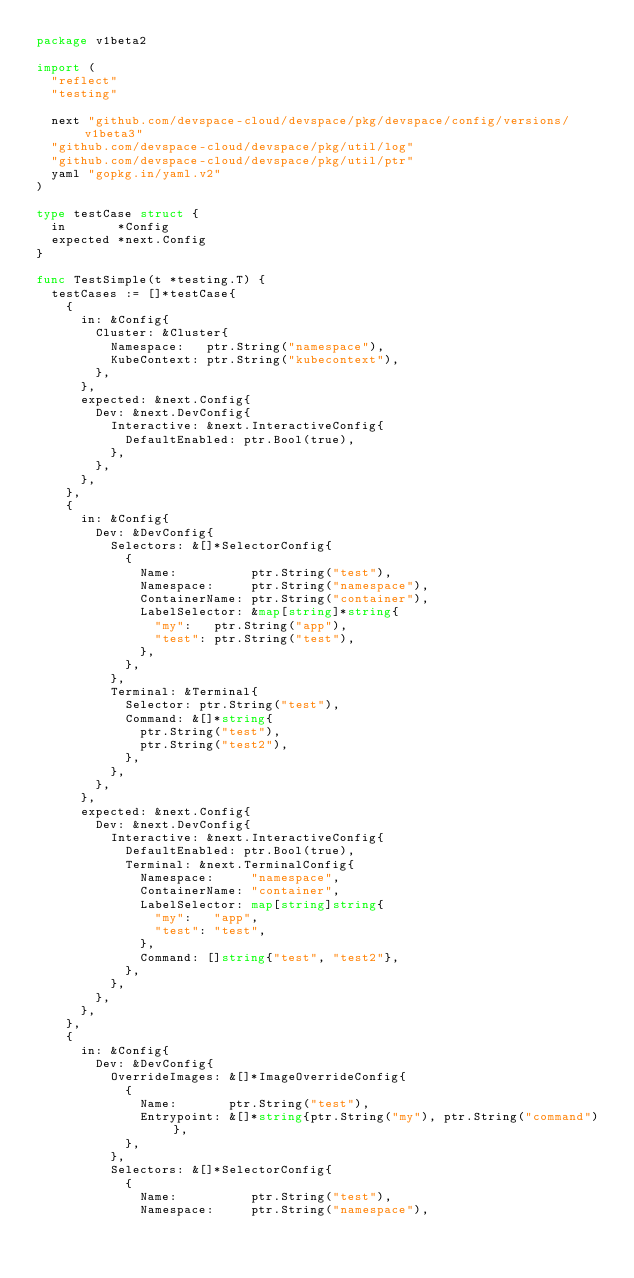Convert code to text. <code><loc_0><loc_0><loc_500><loc_500><_Go_>package v1beta2

import (
	"reflect"
	"testing"

	next "github.com/devspace-cloud/devspace/pkg/devspace/config/versions/v1beta3"
	"github.com/devspace-cloud/devspace/pkg/util/log"
	"github.com/devspace-cloud/devspace/pkg/util/ptr"
	yaml "gopkg.in/yaml.v2"
)

type testCase struct {
	in       *Config
	expected *next.Config
}

func TestSimple(t *testing.T) {
	testCases := []*testCase{
		{
			in: &Config{
				Cluster: &Cluster{
					Namespace:   ptr.String("namespace"),
					KubeContext: ptr.String("kubecontext"),
				},
			},
			expected: &next.Config{
				Dev: &next.DevConfig{
					Interactive: &next.InteractiveConfig{
						DefaultEnabled: ptr.Bool(true),
					},
				},
			},
		},
		{
			in: &Config{
				Dev: &DevConfig{
					Selectors: &[]*SelectorConfig{
						{
							Name:          ptr.String("test"),
							Namespace:     ptr.String("namespace"),
							ContainerName: ptr.String("container"),
							LabelSelector: &map[string]*string{
								"my":   ptr.String("app"),
								"test": ptr.String("test"),
							},
						},
					},
					Terminal: &Terminal{
						Selector: ptr.String("test"),
						Command: &[]*string{
							ptr.String("test"),
							ptr.String("test2"),
						},
					},
				},
			},
			expected: &next.Config{
				Dev: &next.DevConfig{
					Interactive: &next.InteractiveConfig{
						DefaultEnabled: ptr.Bool(true),
						Terminal: &next.TerminalConfig{
							Namespace:     "namespace",
							ContainerName: "container",
							LabelSelector: map[string]string{
								"my":   "app",
								"test": "test",
							},
							Command: []string{"test", "test2"},
						},
					},
				},
			},
		},
		{
			in: &Config{
				Dev: &DevConfig{
					OverrideImages: &[]*ImageOverrideConfig{
						{
							Name:       ptr.String("test"),
							Entrypoint: &[]*string{ptr.String("my"), ptr.String("command")},
						},
					},
					Selectors: &[]*SelectorConfig{
						{
							Name:          ptr.String("test"),
							Namespace:     ptr.String("namespace"),</code> 